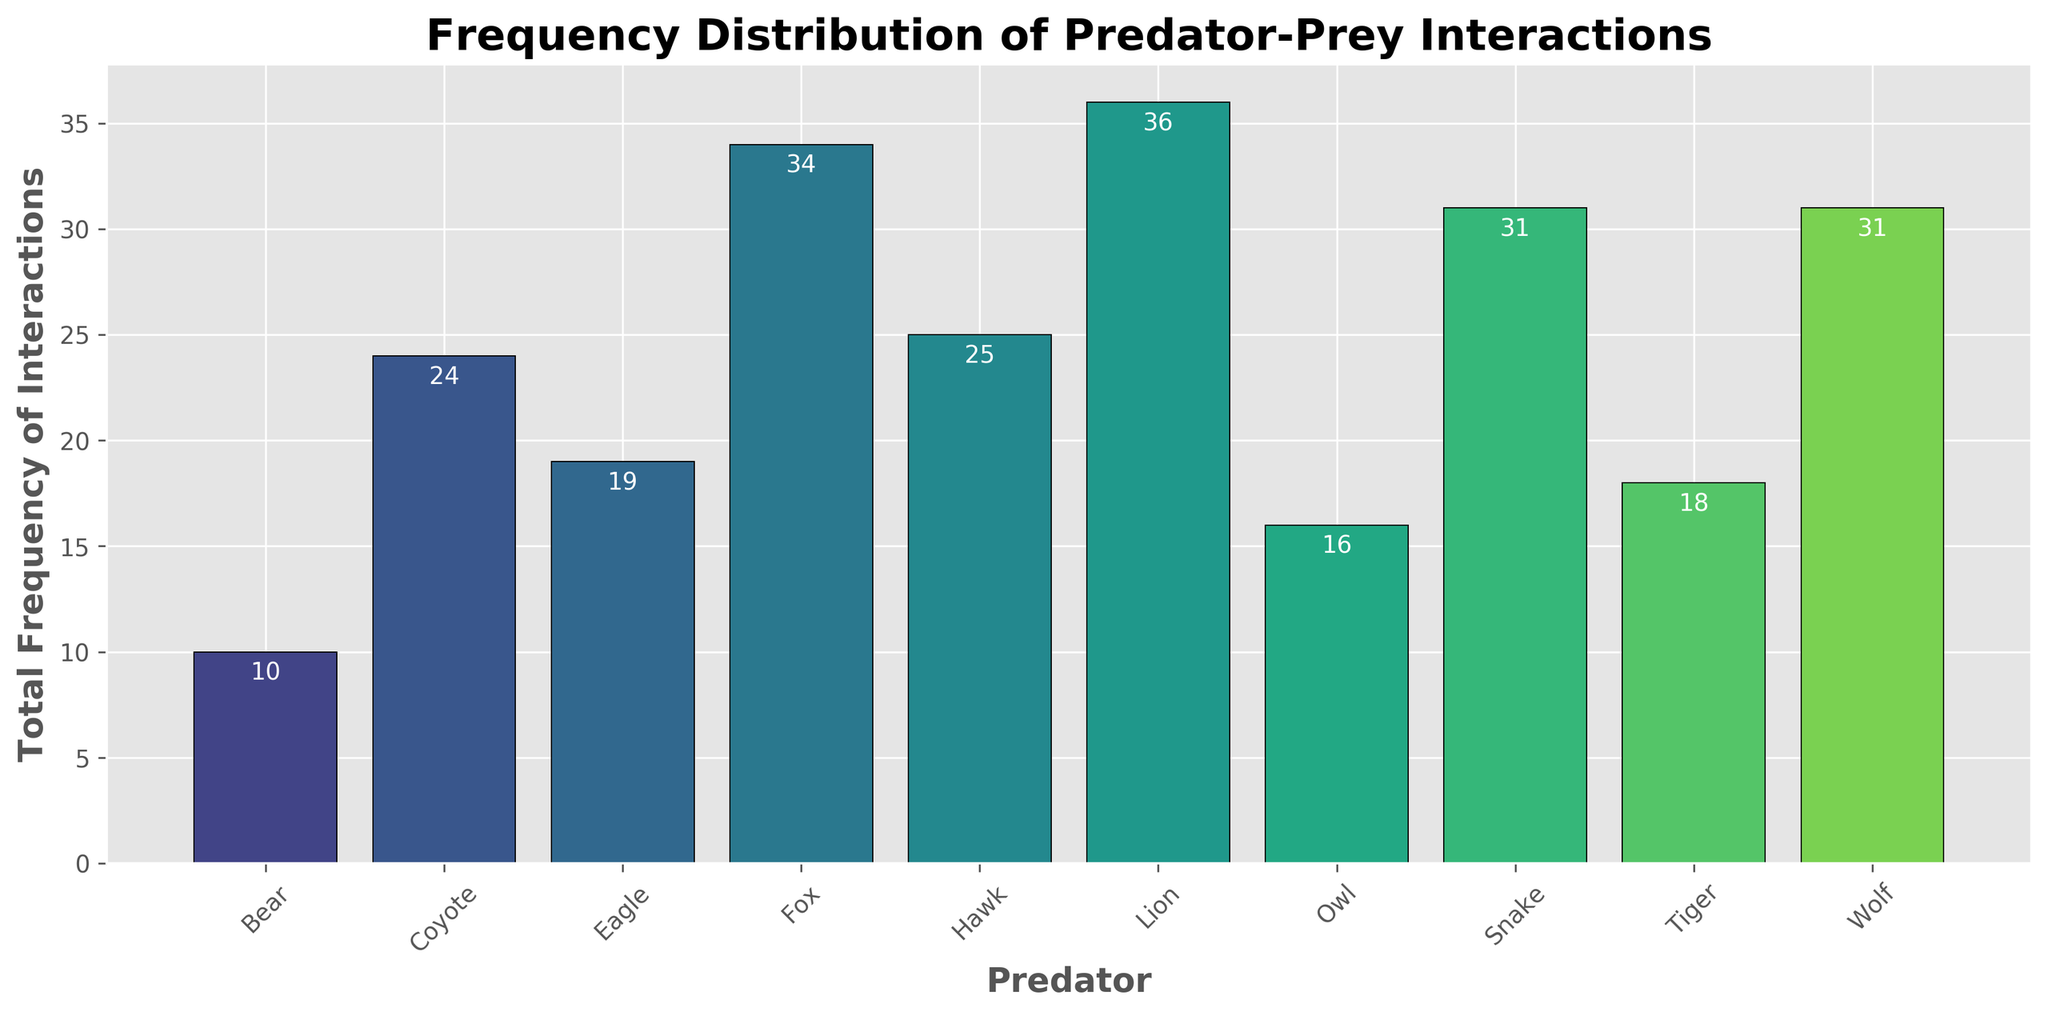What's the total frequency of prey interactions for the Hawk and Fox combined? First, identify the total frequency for the Hawk: 15 (Mouse) + 10 (Rabbit) = 25. Next, identify the total frequency for the Fox: 12 (Mouse) + 22 (Rabbit) = 34. Add the frequencies of both predators: 25 + 34 = 59.
Answer: 59 Which predator has the highest total frequency of interactions? Look for the bar with the greatest height in the histogram. The Lion has the highest frequency with a total of 36 interactions.
Answer: Lion What is the difference in the total frequency of interactions between Bear and Coyote? Identify the total frequency for the Bear: 6 (Rabbit) + 4 (Deer) = 10. Identify the total frequency for the Coyote: 19 (Rabbit) + 5 (Frog) = 24. Calculate the difference: 24 - 10 = 14.
Answer: 14 Which predators have a total frequency of interactions less than 20? Identify the heights of bars that are lower than the threshold of 20. The predators are Owl (16), Bear (10), Eagle (19), and Tiger (18).
Answer: Owl, Bear, Eagle, Tiger What's the combined frequency of interactions for all bird predators (Hawk, Eagle, Owl)? Sum the frequencies for Hawk: 25, Eagle: 19, and Owl: 16. Calculate the total: 25 + 19 + 16 = 60.
Answer: 60 What is the range of the total frequency of interactions among all predators? Identify the highest frequency (Lion with 36) and the lowest frequency (Bear with 10). Calculate the range: 36 - 10 = 26.
Answer: 26 What proportion of the total frequency of interactions do the Lion and Tiger together account for? Calculate the total frequency for Lion (36) and Tiger (18), adding them gives 54. Sum the total frequencies for all predators (209). Calculate the proportion: 54 / 209 ≈ 0.258, or 25.8%.
Answer: 25.8% How many predators have a total frequency of interactions greater than the average frequency of all predators? Calculate the total frequency of interactions for all predators (209) and the number of predators (10). Average frequency: 209 / 10 = 20.9. Check which predators have more than 20.9: Fox, Lion, and Wolf. Count them: 3 predators.
Answer: 3 Which predator has a total frequency equal to the median frequency of all predators? List the total frequencies: [36, 34, 31, 29, 25, 25, 19, 18, 17, 10]. The median is the average of 5th and 6th values: (25 + 25)/2 = 25. The Hawk and Coyote both have a total frequency of 25.
Answer: Hawk, Coyote 